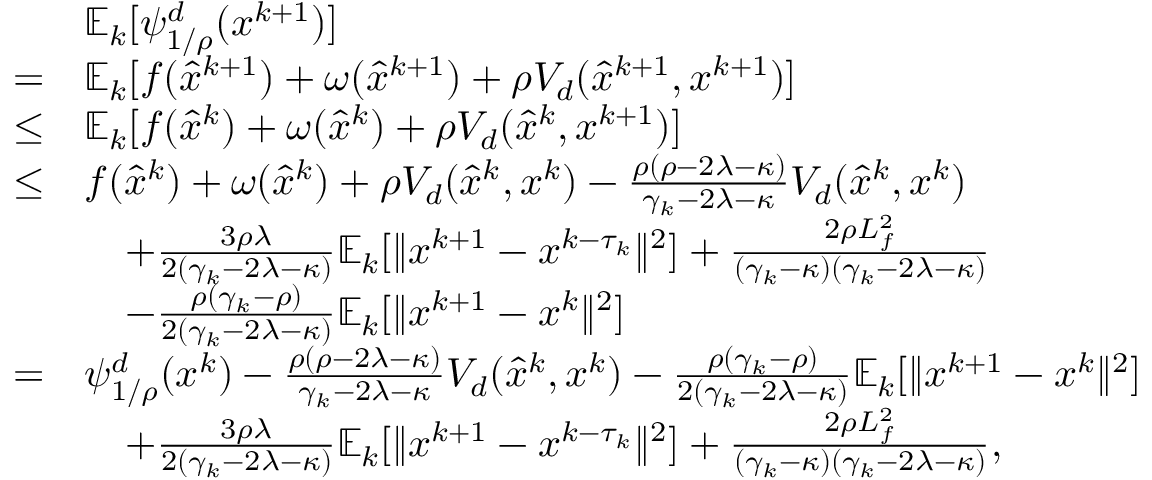<formula> <loc_0><loc_0><loc_500><loc_500>\begin{array} { r l } & { \mathbb { E } _ { k } [ \psi _ { 1 / \rho } ^ { d } ( x ^ { k + 1 } ) ] } \\ { = } & { \mathbb { E } _ { k } [ f ( \hat { x } ^ { k + 1 } ) + \omega ( \hat { x } ^ { k + 1 } ) + \rho V _ { d } ( \hat { x } ^ { k + 1 } , x ^ { k + 1 } ) ] } \\ { \leq } & { \mathbb { E } _ { k } [ f ( \hat { x } ^ { k } ) + \omega ( \hat { x } ^ { k } ) + \rho V _ { d } ( \hat { x } ^ { k } , x ^ { k + 1 } ) ] } \\ { \leq } & { f ( \hat { x } ^ { k } ) + \omega ( \hat { x } ^ { k } ) + \rho V _ { d } ( \hat { x } ^ { k } , x ^ { k } ) - \frac { \rho ( \rho - 2 \lambda - \kappa ) } { \gamma _ { k } - 2 \lambda - \kappa } V _ { d } ( \hat { x } ^ { k } , x ^ { k } ) } \\ & { \quad + \frac { 3 \rho \lambda } { 2 ( \gamma _ { k } - 2 \lambda - \kappa ) } \mathbb { E } _ { k } [ \| x ^ { k + 1 } - x ^ { k - \tau _ { k } } \| ^ { 2 } ] + \frac { 2 \rho L _ { f } ^ { 2 } } { ( \gamma _ { k } - \kappa ) ( \gamma _ { k } - 2 \lambda - \kappa ) } } \\ & { \quad - \frac { \rho ( \gamma _ { k } - \rho ) } { 2 ( \gamma _ { k } - 2 \lambda - \kappa ) } \mathbb { E } _ { k } [ \| x ^ { k + 1 } - x ^ { k } \| ^ { 2 } ] } \\ { = } & { \psi _ { 1 / \rho } ^ { d } ( x ^ { k } ) - \frac { \rho ( \rho - 2 \lambda - \kappa ) } { \gamma _ { k } - 2 \lambda - \kappa } V _ { d } ( \hat { x } ^ { k } , x ^ { k } ) - \frac { \rho ( \gamma _ { k } - \rho ) } { 2 ( \gamma _ { k } - 2 \lambda - \kappa ) } \mathbb { E } _ { k } [ \| x ^ { k + 1 } - x ^ { k } \| ^ { 2 } ] } \\ & { \quad + \frac { 3 \rho \lambda } { 2 ( \gamma _ { k } - 2 \lambda - \kappa ) } \mathbb { E } _ { k } [ \| x ^ { k + 1 } - x ^ { k - \tau _ { k } } \| ^ { 2 } ] + \frac { 2 \rho L _ { f } ^ { 2 } } { ( \gamma _ { k } - \kappa ) ( \gamma _ { k } - 2 \lambda - \kappa ) } , } \end{array}</formula> 